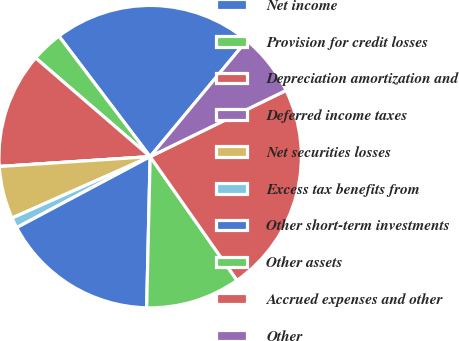<chart> <loc_0><loc_0><loc_500><loc_500><pie_chart><fcel>Net income<fcel>Provision for credit losses<fcel>Depreciation amortization and<fcel>Deferred income taxes<fcel>Net securities losses<fcel>Excess tax benefits from<fcel>Other short-term investments<fcel>Other assets<fcel>Accrued expenses and other<fcel>Other<nl><fcel>21.35%<fcel>3.37%<fcel>12.36%<fcel>0.0%<fcel>5.62%<fcel>1.12%<fcel>16.85%<fcel>10.11%<fcel>22.47%<fcel>6.74%<nl></chart> 